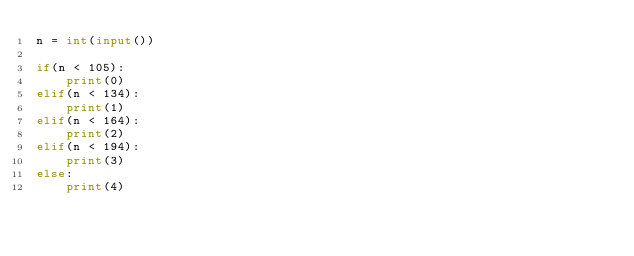<code> <loc_0><loc_0><loc_500><loc_500><_Python_>n = int(input())

if(n < 105):
    print(0)
elif(n < 134):
    print(1)
elif(n < 164):
    print(2)
elif(n < 194):
    print(3)
else:
    print(4)
</code> 